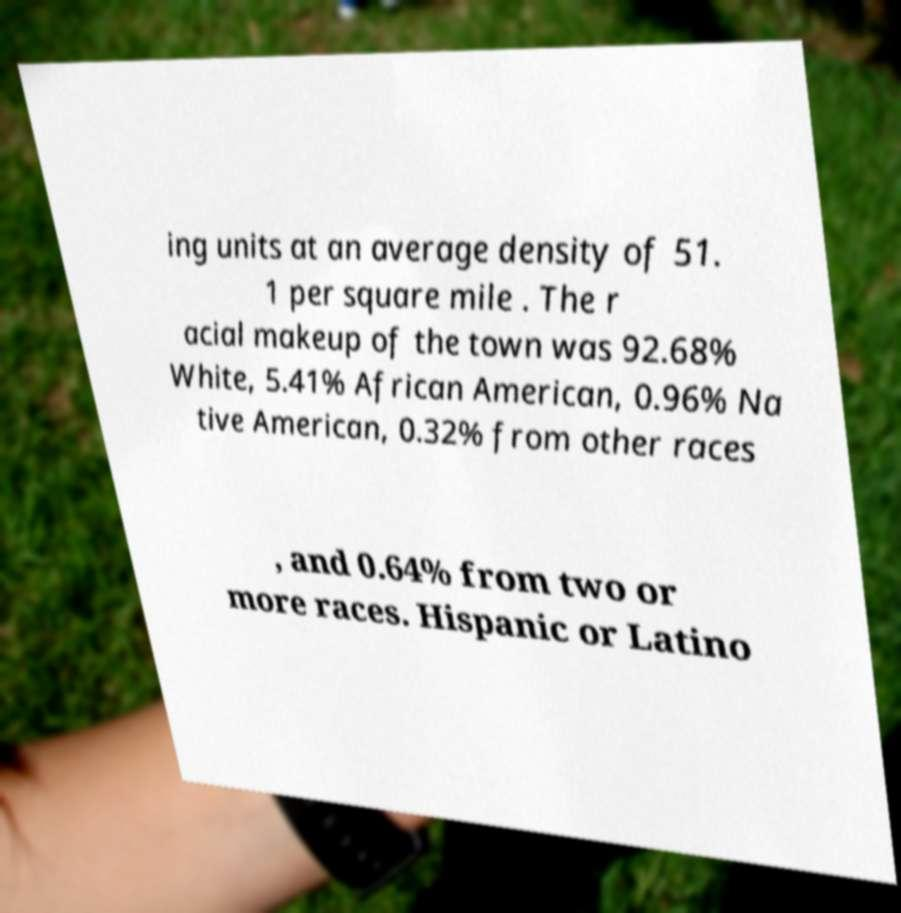Could you extract and type out the text from this image? ing units at an average density of 51. 1 per square mile . The r acial makeup of the town was 92.68% White, 5.41% African American, 0.96% Na tive American, 0.32% from other races , and 0.64% from two or more races. Hispanic or Latino 